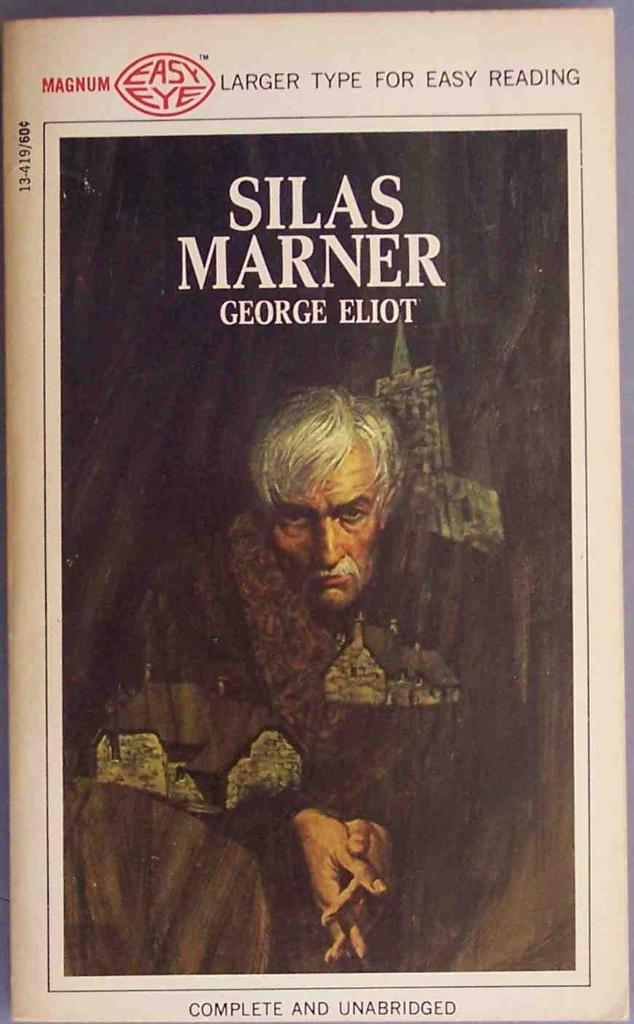<image>
Create a compact narrative representing the image presented. A large print version of the book Silas Marner by George Eliot. 